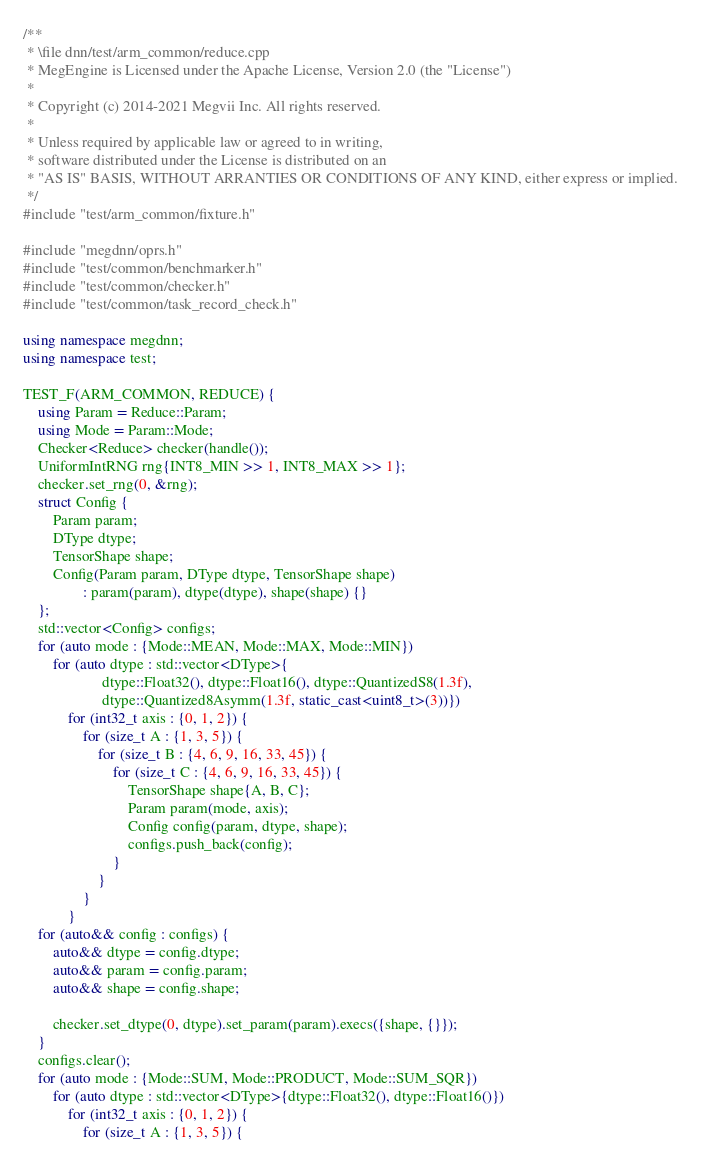Convert code to text. <code><loc_0><loc_0><loc_500><loc_500><_C++_>/**
 * \file dnn/test/arm_common/reduce.cpp
 * MegEngine is Licensed under the Apache License, Version 2.0 (the "License")
 *
 * Copyright (c) 2014-2021 Megvii Inc. All rights reserved.
 *
 * Unless required by applicable law or agreed to in writing,
 * software distributed under the License is distributed on an
 * "AS IS" BASIS, WITHOUT ARRANTIES OR CONDITIONS OF ANY KIND, either express or implied.
 */
#include "test/arm_common/fixture.h"

#include "megdnn/oprs.h"
#include "test/common/benchmarker.h"
#include "test/common/checker.h"
#include "test/common/task_record_check.h"

using namespace megdnn;
using namespace test;

TEST_F(ARM_COMMON, REDUCE) {
    using Param = Reduce::Param;
    using Mode = Param::Mode;
    Checker<Reduce> checker(handle());
    UniformIntRNG rng{INT8_MIN >> 1, INT8_MAX >> 1};
    checker.set_rng(0, &rng);
    struct Config {
        Param param;
        DType dtype;
        TensorShape shape;
        Config(Param param, DType dtype, TensorShape shape)
                : param(param), dtype(dtype), shape(shape) {}
    };
    std::vector<Config> configs;
    for (auto mode : {Mode::MEAN, Mode::MAX, Mode::MIN})
        for (auto dtype : std::vector<DType>{
                     dtype::Float32(), dtype::Float16(), dtype::QuantizedS8(1.3f),
                     dtype::Quantized8Asymm(1.3f, static_cast<uint8_t>(3))})
            for (int32_t axis : {0, 1, 2}) {
                for (size_t A : {1, 3, 5}) {
                    for (size_t B : {4, 6, 9, 16, 33, 45}) {
                        for (size_t C : {4, 6, 9, 16, 33, 45}) {
                            TensorShape shape{A, B, C};
                            Param param(mode, axis);
                            Config config(param, dtype, shape);
                            configs.push_back(config);
                        }
                    }
                }
            }
    for (auto&& config : configs) {
        auto&& dtype = config.dtype;
        auto&& param = config.param;
        auto&& shape = config.shape;

        checker.set_dtype(0, dtype).set_param(param).execs({shape, {}});
    }
    configs.clear();
    for (auto mode : {Mode::SUM, Mode::PRODUCT, Mode::SUM_SQR})
        for (auto dtype : std::vector<DType>{dtype::Float32(), dtype::Float16()})
            for (int32_t axis : {0, 1, 2}) {
                for (size_t A : {1, 3, 5}) {</code> 